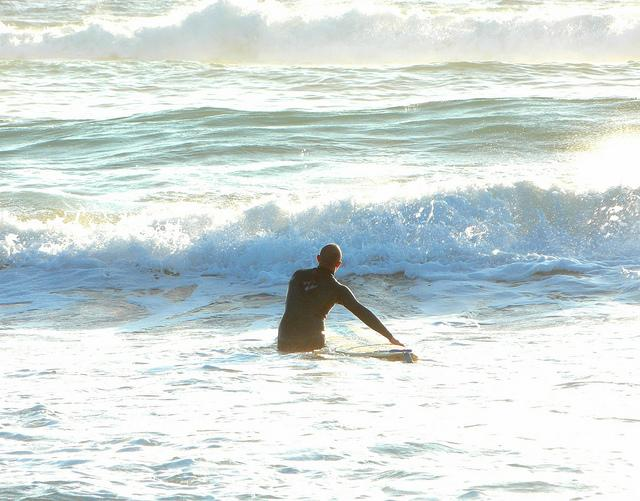World surf league is the highest governing body of which sport?

Choices:
A) kiting
B) swimming
C) skating
D) surfing surfing 